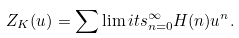<formula> <loc_0><loc_0><loc_500><loc_500>Z _ { K } ( u ) = \sum \lim i t s _ { n = 0 } ^ { \infty } H ( n ) u ^ { n } .</formula> 